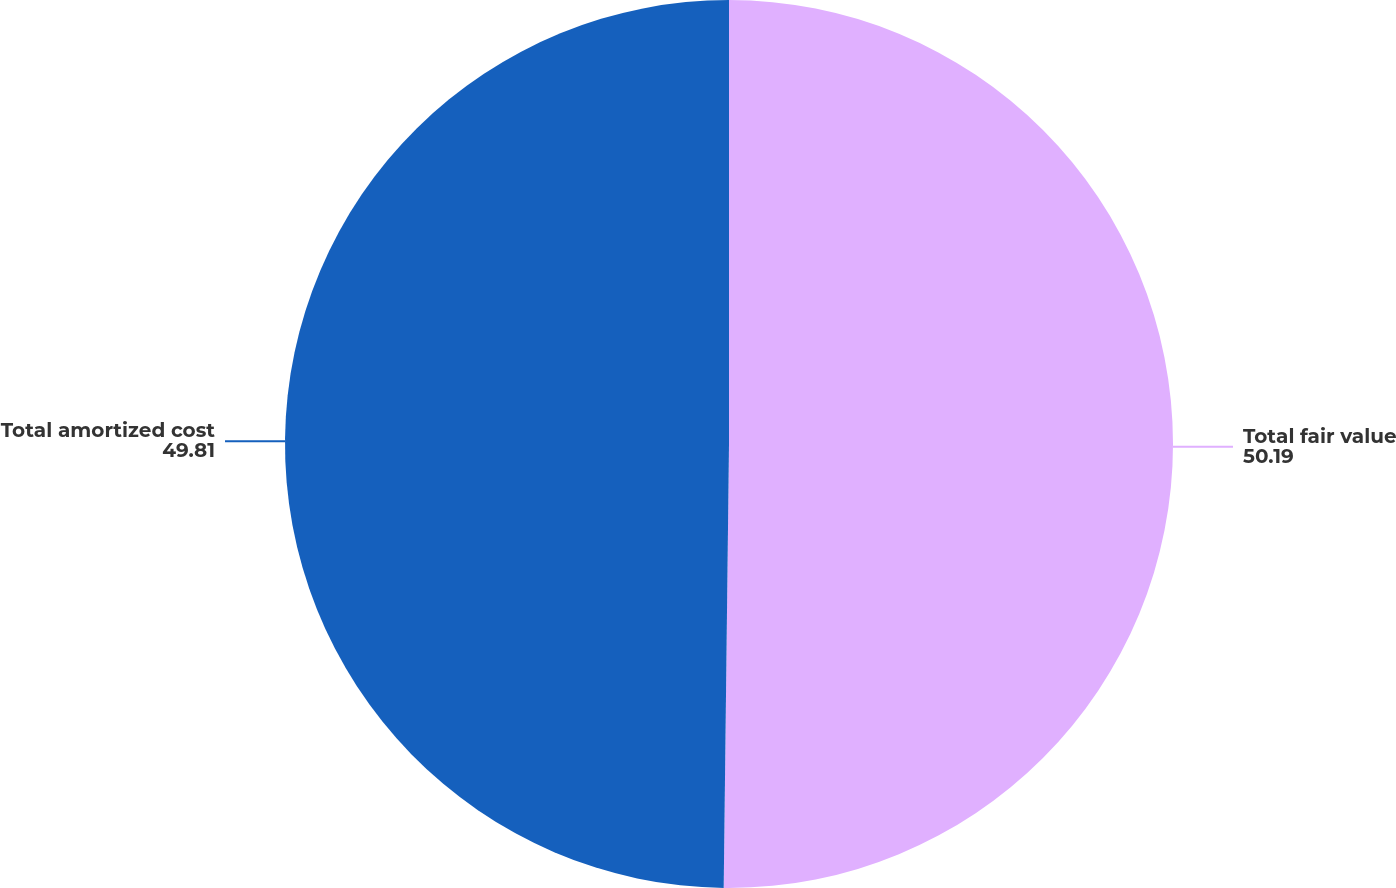<chart> <loc_0><loc_0><loc_500><loc_500><pie_chart><fcel>Total fair value<fcel>Total amortized cost<nl><fcel>50.19%<fcel>49.81%<nl></chart> 